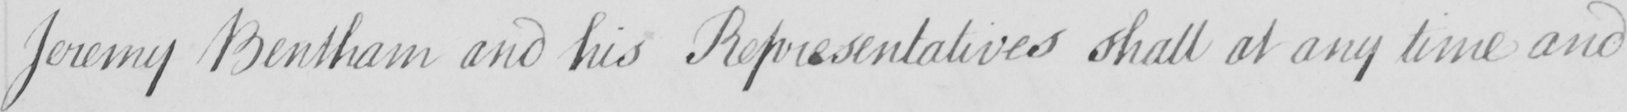What is written in this line of handwriting? Jeremy Bentham and his Representatives shall at any time and 